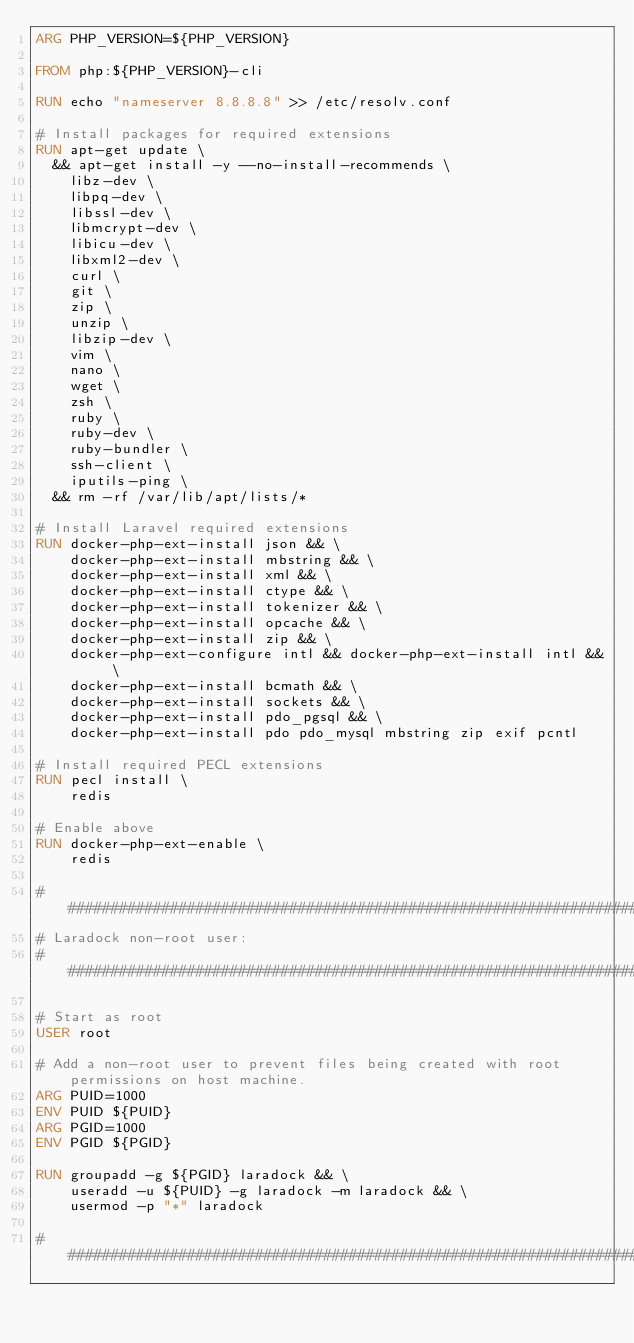Convert code to text. <code><loc_0><loc_0><loc_500><loc_500><_Dockerfile_>ARG PHP_VERSION=${PHP_VERSION}

FROM php:${PHP_VERSION}-cli

RUN echo "nameserver 8.8.8.8" >> /etc/resolv.conf

# Install packages for required extensions
RUN apt-get update \
  && apt-get install -y --no-install-recommends \
    libz-dev \
    libpq-dev \
    libssl-dev \
    libmcrypt-dev \
    libicu-dev \
    libxml2-dev \
    curl \
    git \
    zip \
    unzip \
    libzip-dev \
    vim \
    nano \
    wget \
    zsh \
    ruby \
    ruby-dev \
    ruby-bundler \
    ssh-client \
    iputils-ping \
  && rm -rf /var/lib/apt/lists/*

# Install Laravel required extensions
RUN docker-php-ext-install json && \
    docker-php-ext-install mbstring && \
    docker-php-ext-install xml && \
    docker-php-ext-install ctype && \
    docker-php-ext-install tokenizer && \
    docker-php-ext-install opcache && \
    docker-php-ext-install zip && \
    docker-php-ext-configure intl && docker-php-ext-install intl && \
    docker-php-ext-install bcmath && \
    docker-php-ext-install sockets && \
    docker-php-ext-install pdo_pgsql && \
    docker-php-ext-install pdo pdo_mysql mbstring zip exif pcntl

# Install required PECL extensions
RUN pecl install \
    redis

# Enable above
RUN docker-php-ext-enable \
    redis

###########################################################################
# Laradock non-root user:
###########################################################################

# Start as root
USER root

# Add a non-root user to prevent files being created with root permissions on host machine.
ARG PUID=1000
ENV PUID ${PUID}
ARG PGID=1000
ENV PGID ${PGID}

RUN groupadd -g ${PGID} laradock && \
    useradd -u ${PUID} -g laradock -m laradock && \
    usermod -p "*" laradock

###########################################################################</code> 